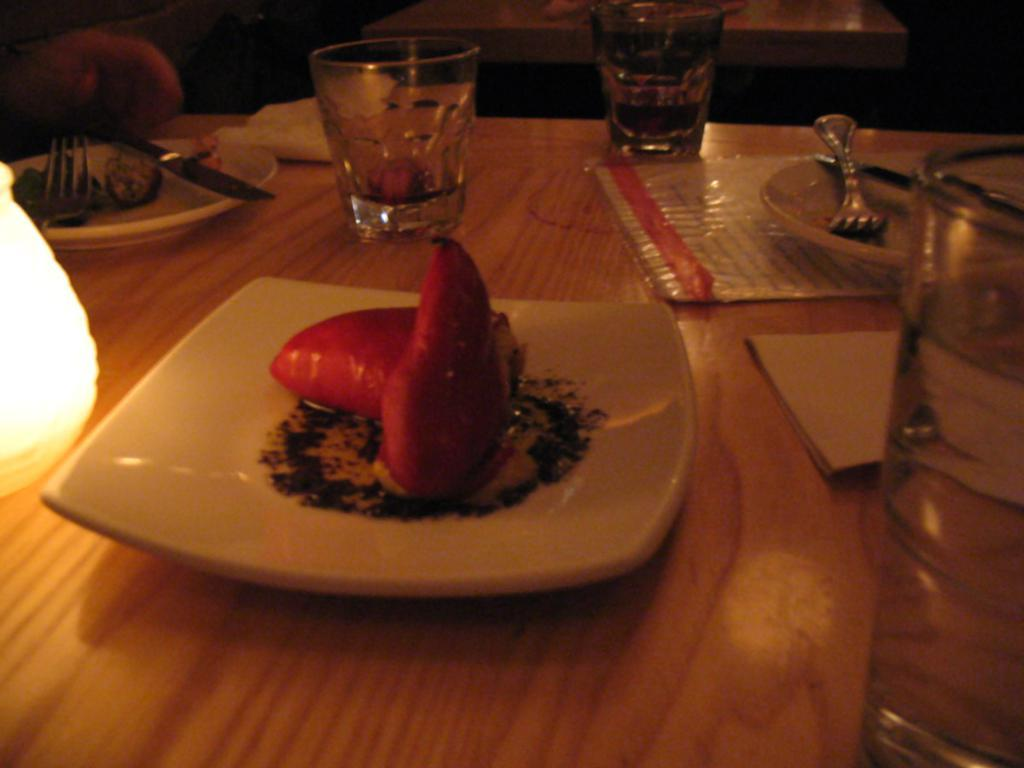What piece of furniture is present in the image? There is a table in the image. What items can be seen on the table? There are glasses, plates with food, and spoons on the table. What type of light is visible in the image? There is a light in the image. What can be used for cleaning or wiping in the image? There are tissues in the image. What type of pet can be seen playing with a comb in the image? There is no pet or comb present in the image. 